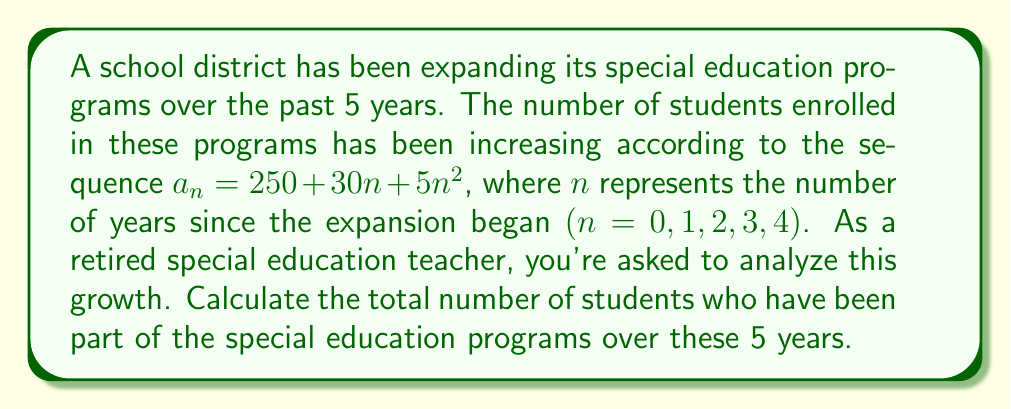Could you help me with this problem? To solve this problem, we need to follow these steps:

1) First, let's calculate the number of students for each year:

   Year 0 (start): $a_0 = 250 + 30(0) + 5(0)^2 = 250$
   Year 1: $a_1 = 250 + 30(1) + 5(1)^2 = 285$
   Year 2: $a_2 = 250 + 30(2) + 5(2)^2 = 330$
   Year 3: $a_3 = 250 + 30(3) + 5(3)^2 = 395$
   Year 4: $a_4 = 250 + 30(4) + 5(4)^2 = 480$

2) To find the total number of students over these 5 years, we need to sum these values:

   $$S_5 = a_0 + a_1 + a_2 + a_3 + a_4$$

3) We can calculate this sum directly:

   $$S_5 = 250 + 285 + 330 + 395 + 480 = 1740$$

4) Alternatively, we can recognize this as an arithmetic sequence of the second order. For such sequences, there's a formula for the sum of the first $n$ terms:

   $$S_n = \frac{n}{6}[2a + (n-1)(2b+c) + (n-1)(n-2)c]$$

   Where $a$ is the first term, and $b$ and $c$ are the coefficients of $n$ and $n^2$ respectively in the general term.

5) In our case, $n = 5$, $a = 250$, $b = 30$, and $c = 5$. Substituting these values:

   $$S_5 = \frac{5}{6}[2(250) + (5-1)(2(30)+5) + (5-1)(5-2)5]$$
   $$= \frac{5}{6}[500 + 4(65) + 12(5)]$$
   $$= \frac{5}{6}[500 + 260 + 60]$$
   $$= \frac{5}{6}[820] = 1740$$

This confirms our direct calculation.
Answer: The total number of students who have been part of the special education programs over these 5 years is 1740. 